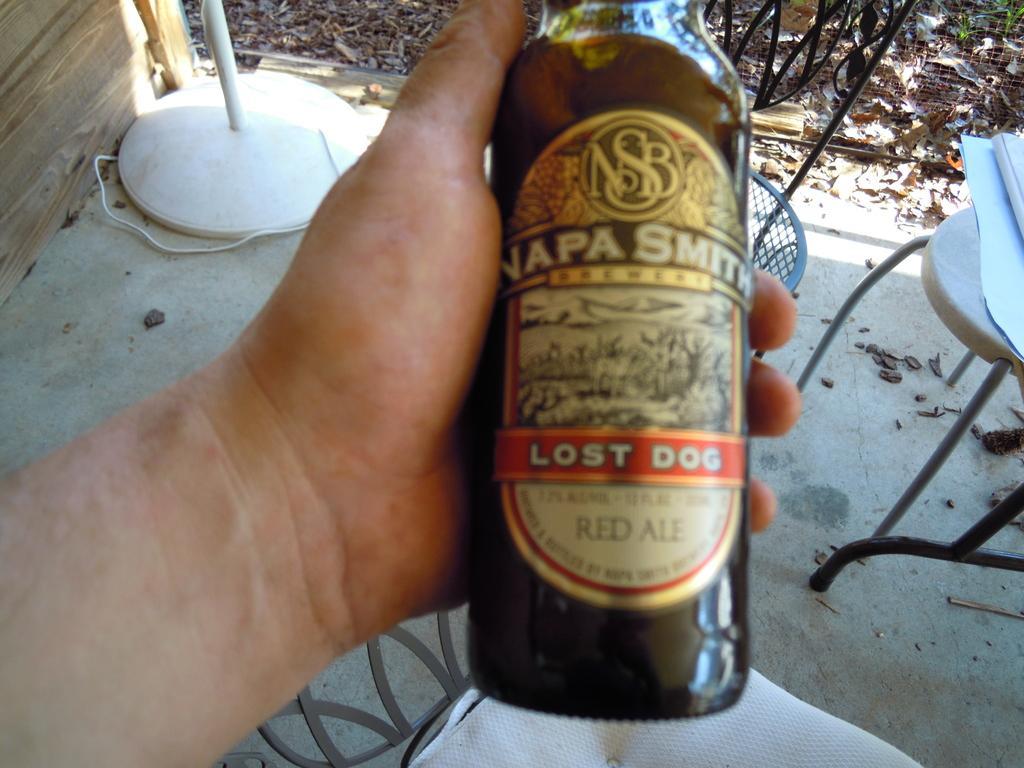Can you describe this image briefly? This is a picture taken in the outdoor. A person is holding a bottle under the bottle there is a table covered with a cloth. Behind the bottle there is a fencing and some items on the floor. 